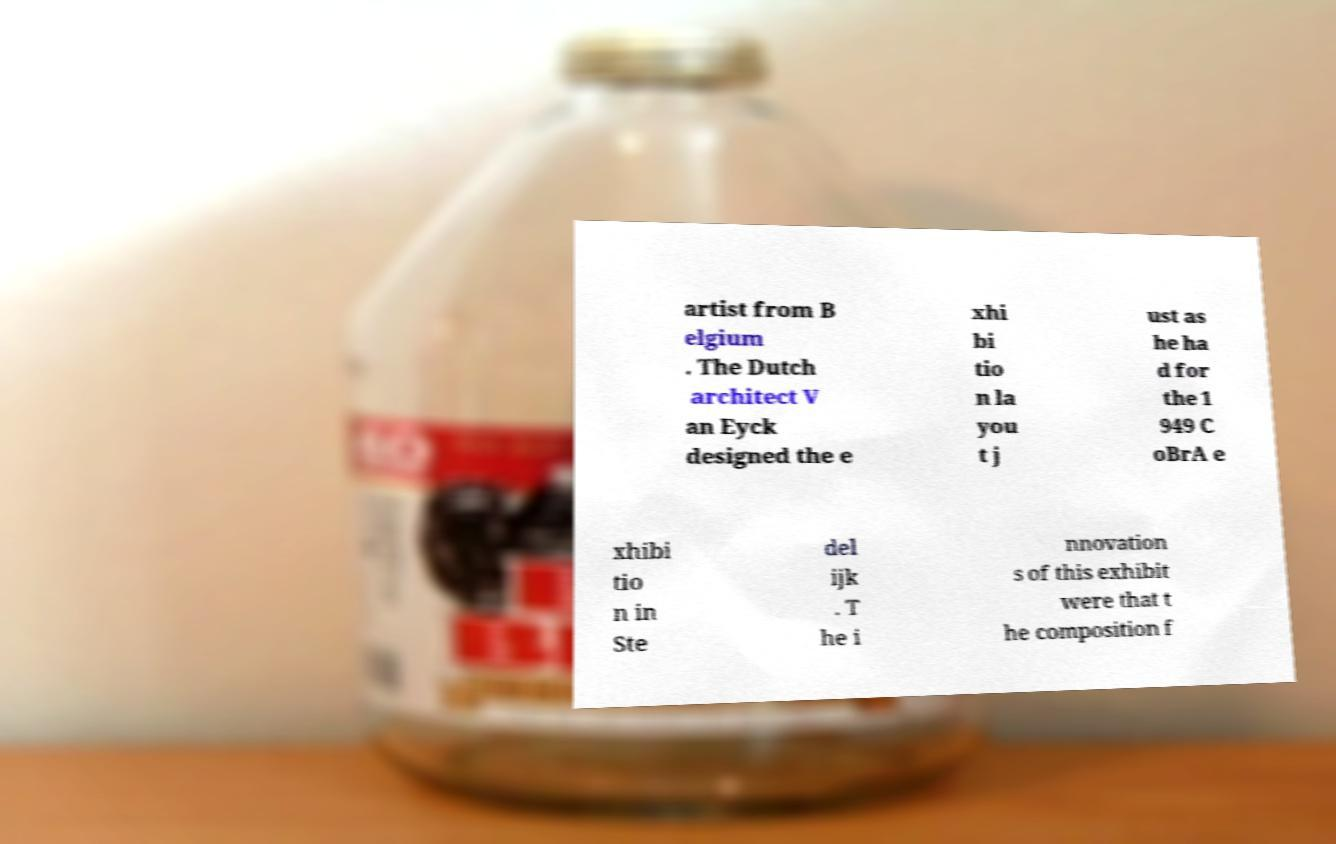What messages or text are displayed in this image? I need them in a readable, typed format. artist from B elgium . The Dutch architect V an Eyck designed the e xhi bi tio n la you t j ust as he ha d for the 1 949 C oBrA e xhibi tio n in Ste del ijk . T he i nnovation s of this exhibit were that t he composition f 